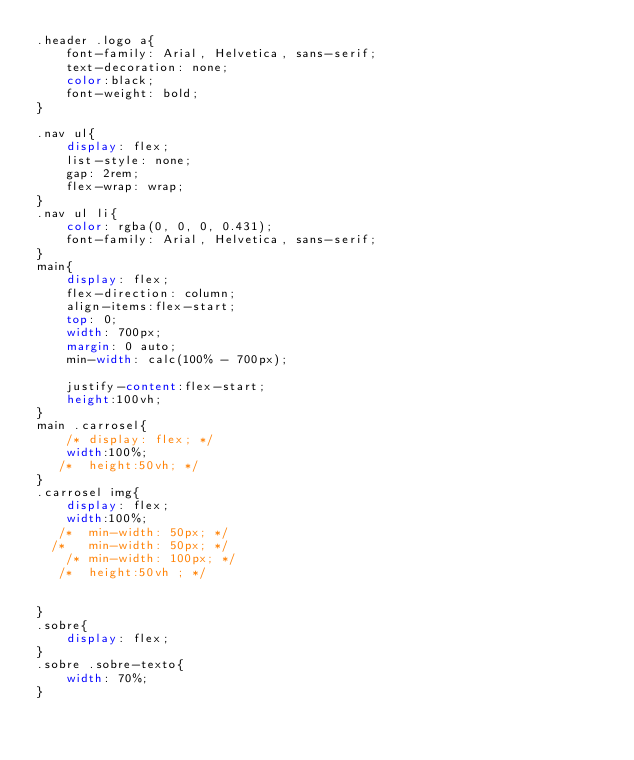Convert code to text. <code><loc_0><loc_0><loc_500><loc_500><_CSS_>.header .logo a{
    font-family: Arial, Helvetica, sans-serif;
    text-decoration: none;
    color:black;
    font-weight: bold;
}

.nav ul{
    display: flex;
    list-style: none;
    gap: 2rem;
    flex-wrap: wrap;
}
.nav ul li{
    color: rgba(0, 0, 0, 0.431);
    font-family: Arial, Helvetica, sans-serif;
}
main{
    display: flex;
    flex-direction: column;
    align-items:flex-start;
    top: 0;
    width: 700px;
    margin: 0 auto;
    min-width: calc(100% - 700px);
   
    justify-content:flex-start;
    height:100vh;
}
main .carrosel{
    /* display: flex; */
    width:100%;  
   /*  height:50vh; */
}
.carrosel img{
    display: flex;
    width:100%;
   /*  min-width: 50px; */
  /*   min-width: 50px; */
    /* min-width: 100px; */
   /*  height:50vh ; */
   

}
.sobre{
    display: flex;
}
.sobre .sobre-texto{
    width: 70%;
}</code> 